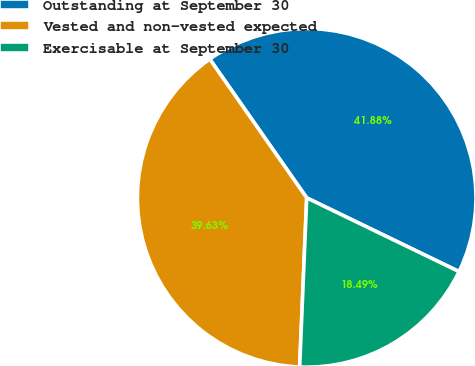Convert chart to OTSL. <chart><loc_0><loc_0><loc_500><loc_500><pie_chart><fcel>Outstanding at September 30<fcel>Vested and non-vested expected<fcel>Exercisable at September 30<nl><fcel>41.88%<fcel>39.63%<fcel>18.49%<nl></chart> 